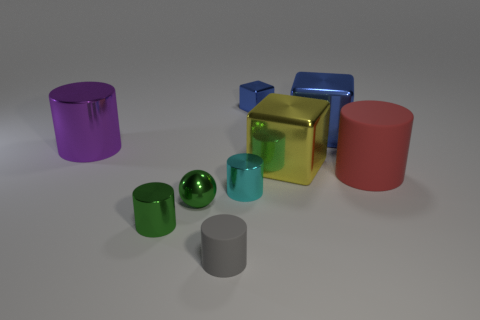Subtract all big purple cylinders. How many cylinders are left? 4 Subtract all cyan cylinders. How many blue blocks are left? 2 Subtract all red cylinders. How many cylinders are left? 4 Subtract all cubes. How many objects are left? 6 Subtract 2 cylinders. How many cylinders are left? 3 Subtract all yellow cylinders. Subtract all red blocks. How many cylinders are left? 5 Add 4 green things. How many green things are left? 6 Add 2 metallic cubes. How many metallic cubes exist? 5 Subtract 0 cyan blocks. How many objects are left? 9 Subtract all gray matte objects. Subtract all small cyan cylinders. How many objects are left? 7 